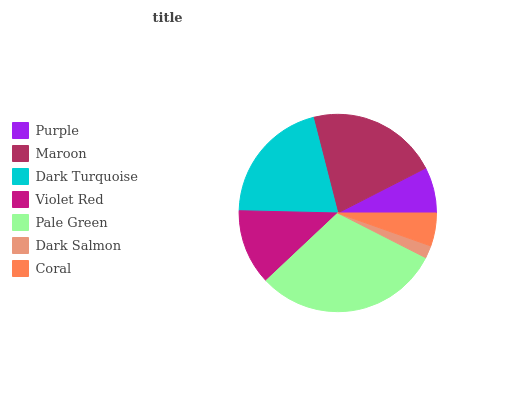Is Dark Salmon the minimum?
Answer yes or no. Yes. Is Pale Green the maximum?
Answer yes or no. Yes. Is Maroon the minimum?
Answer yes or no. No. Is Maroon the maximum?
Answer yes or no. No. Is Maroon greater than Purple?
Answer yes or no. Yes. Is Purple less than Maroon?
Answer yes or no. Yes. Is Purple greater than Maroon?
Answer yes or no. No. Is Maroon less than Purple?
Answer yes or no. No. Is Violet Red the high median?
Answer yes or no. Yes. Is Violet Red the low median?
Answer yes or no. Yes. Is Purple the high median?
Answer yes or no. No. Is Maroon the low median?
Answer yes or no. No. 